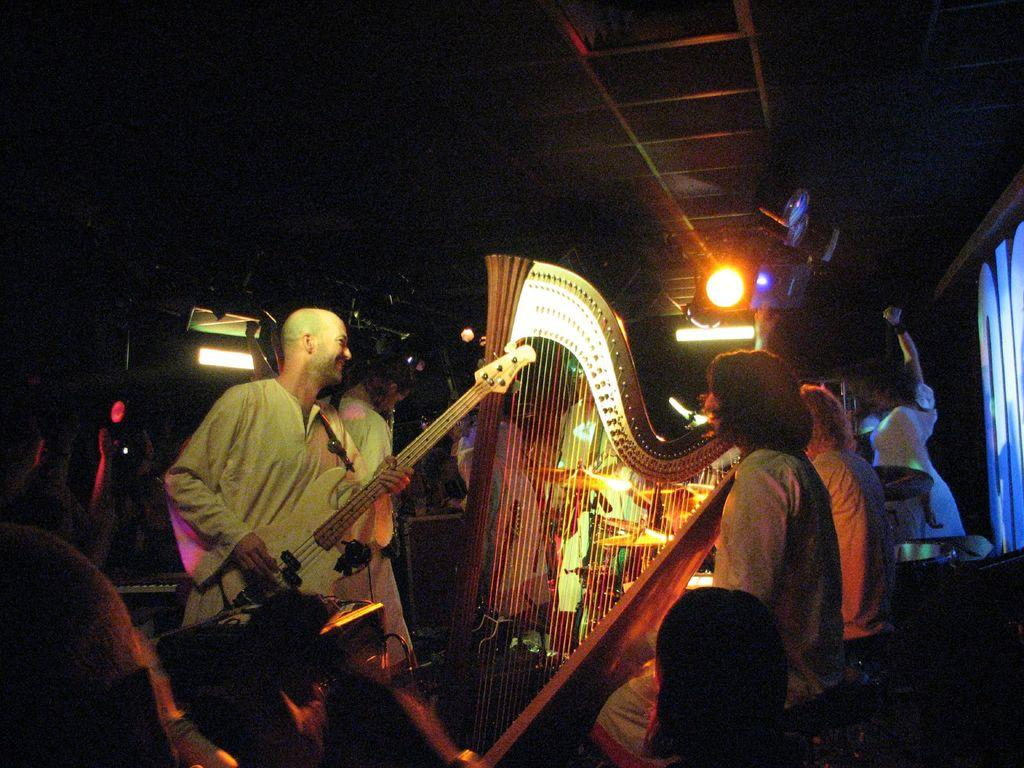What is the person in the image holding? The person in the image is holding a musical instrument. What are the other people in the image doing? There are people sitting in the image. What can be seen in the background of the image? There are lights visible in the background of the image, and the background is dark. What type of zinc object can be seen in the image? There is no zinc object present in the image. 